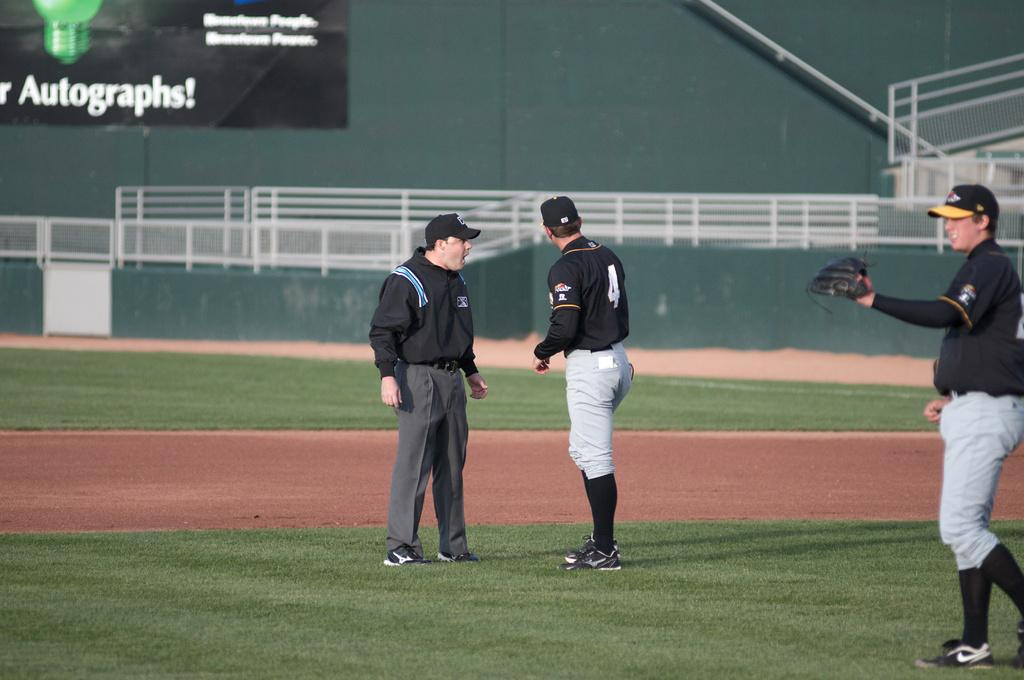<image>
Write a terse but informative summary of the picture. 2 baseball players on the field, with number 2 talking to the coach in front of a sign that advertises Autographs! 